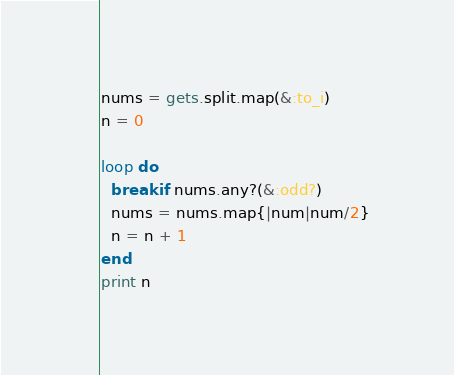Convert code to text. <code><loc_0><loc_0><loc_500><loc_500><_Ruby_>nums = gets.split.map(&:to_i)
n = 0

loop do 
  break if nums.any?(&:odd?)
  nums = nums.map{|num|num/2}
  n = n + 1
end
print n</code> 